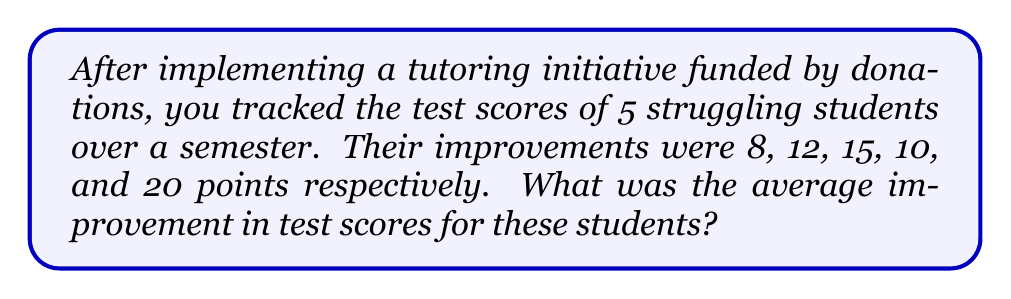Give your solution to this math problem. To find the average improvement in test scores, we need to:

1. Sum up all the improvements
2. Divide the sum by the number of students

Step 1: Calculate the sum of improvements
$$S = 8 + 12 + 15 + 10 + 20 = 65$$

Step 2: Count the number of students
$$n = 5$$

Step 3: Calculate the average improvement
$$\text{Average} = \frac{S}{n} = \frac{65}{5} = 13$$

Therefore, the average improvement in test scores is 13 points.
Answer: 13 points 